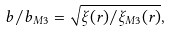Convert formula to latex. <formula><loc_0><loc_0><loc_500><loc_500>b / b _ { M 3 } = \sqrt { \xi ( r ) / \xi _ { M 3 } ( r ) } ,</formula> 